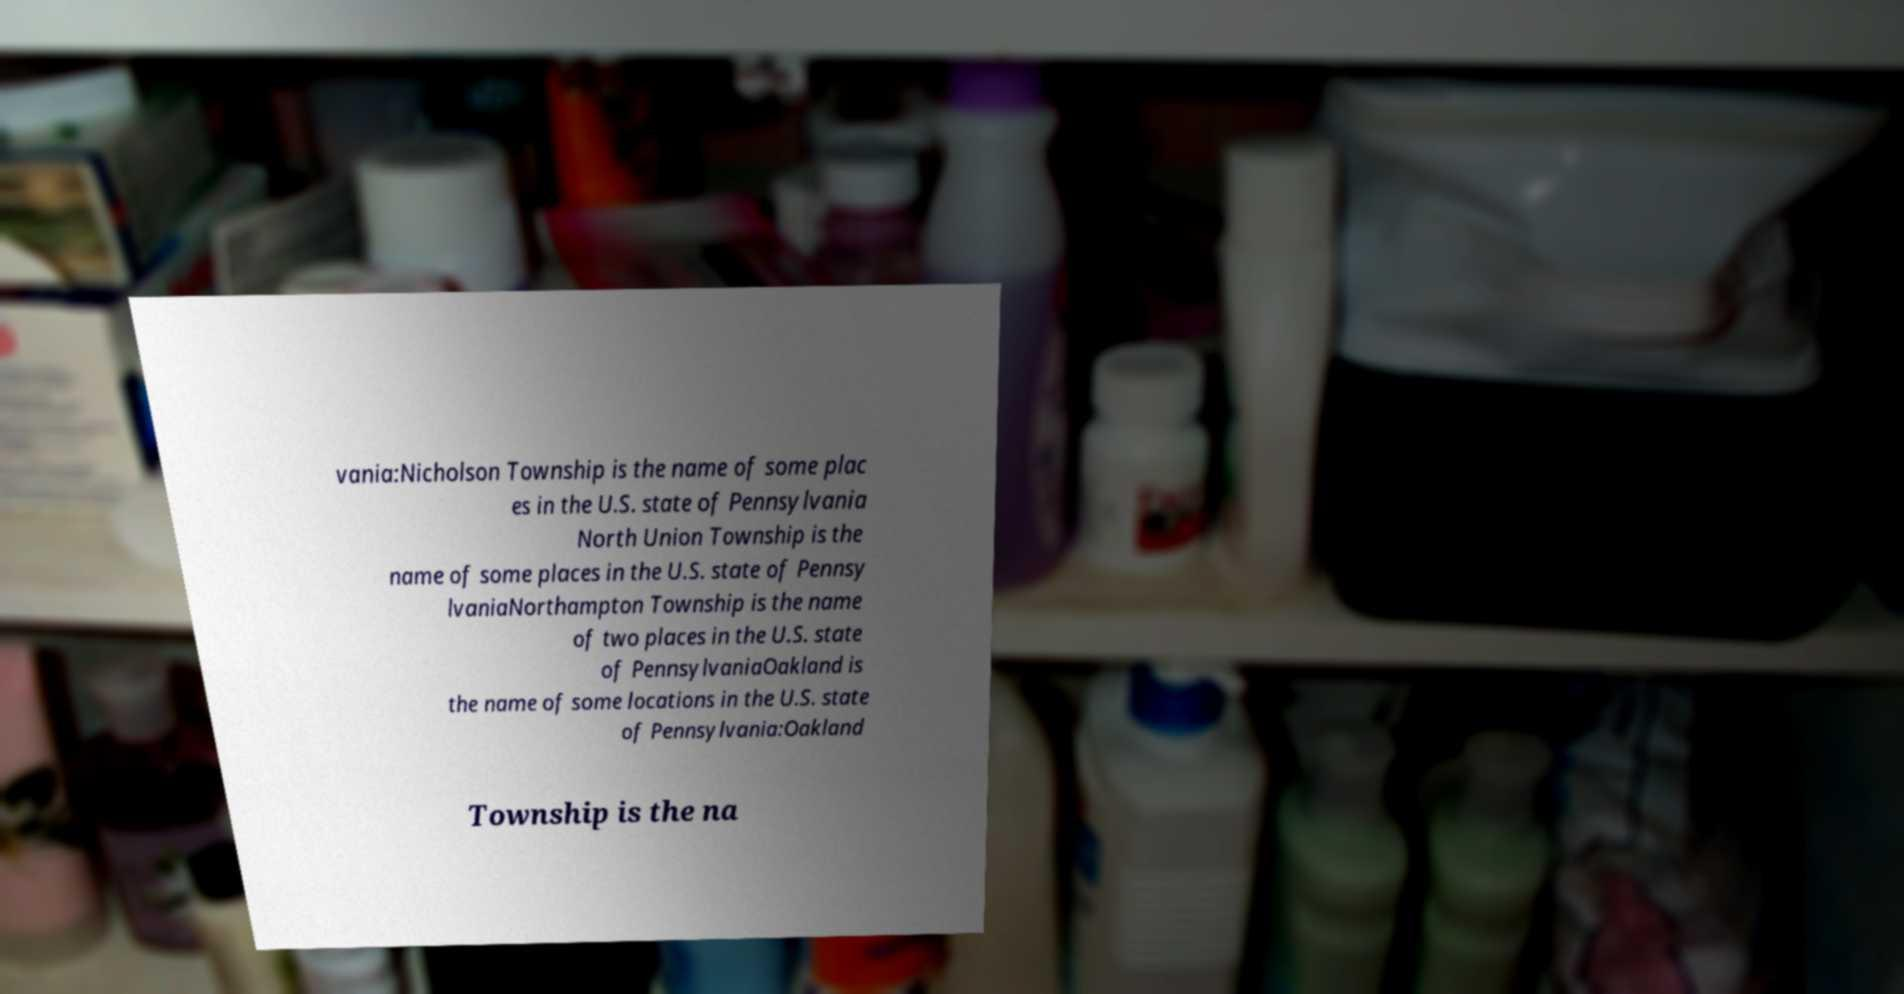Please identify and transcribe the text found in this image. vania:Nicholson Township is the name of some plac es in the U.S. state of Pennsylvania North Union Township is the name of some places in the U.S. state of Pennsy lvaniaNorthampton Township is the name of two places in the U.S. state of PennsylvaniaOakland is the name of some locations in the U.S. state of Pennsylvania:Oakland Township is the na 